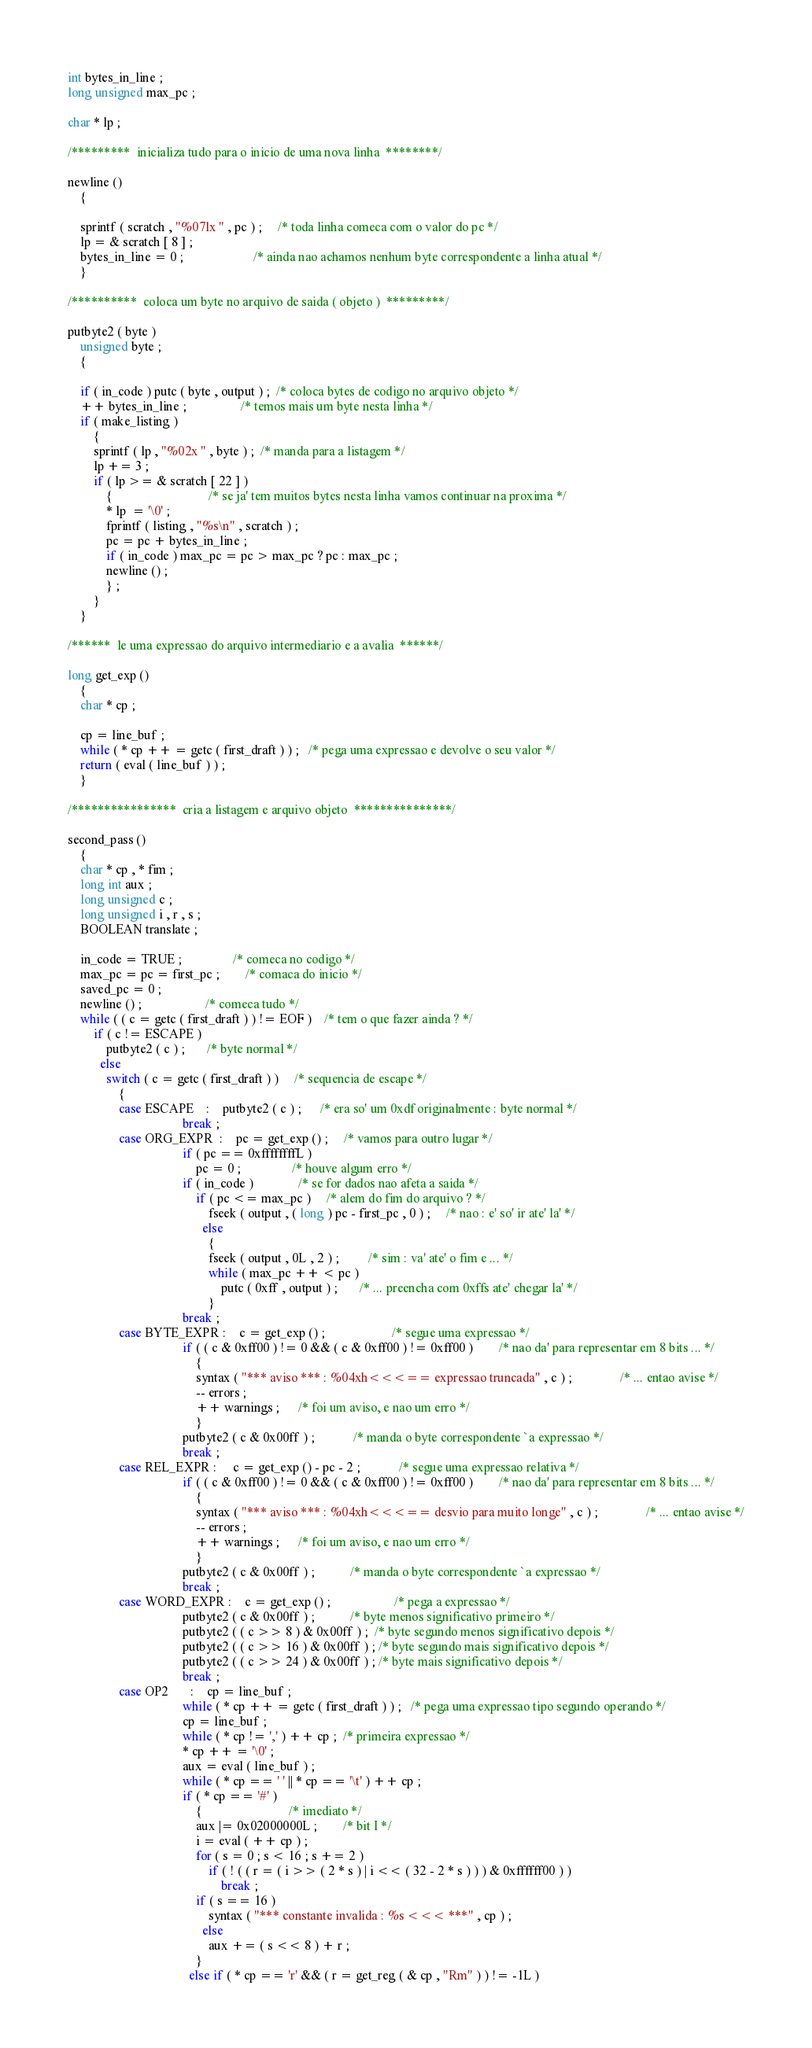Convert code to text. <code><loc_0><loc_0><loc_500><loc_500><_C_>
int bytes_in_line ;
long unsigned max_pc ;

char * lp ;

/*********  inicializa tudo para o inicio de uma nova linha  ********/

newline ()
    {

    sprintf ( scratch , "%07lx " , pc ) ;     /* toda linha comeca com o valor do pc */
    lp = & scratch [ 8 ] ;
    bytes_in_line = 0 ;                      /* ainda nao achamos nenhum byte correspondente a linha atual */
    }

/**********  coloca um byte no arquivo de saida ( objeto )  *********/

putbyte2 ( byte )
    unsigned byte ;
    {

    if ( in_code ) putc ( byte , output ) ;  /* coloca bytes de codigo no arquivo objeto */
    ++ bytes_in_line ;                 /* temos mais um byte nesta linha */
    if ( make_listing )
        {
        sprintf ( lp , "%02x " , byte ) ;  /* manda para a listagem */
        lp += 3 ;
        if ( lp >= & scratch [ 22 ] )
            {                              /* se ja' tem muitos bytes nesta linha vamos continuar na proxima */
            * lp  = '\0' ;
            fprintf ( listing , "%s\n" , scratch ) ;
            pc = pc + bytes_in_line ;
            if ( in_code ) max_pc = pc > max_pc ? pc : max_pc ;
            newline () ;
            } ;
        }
    }

/******  le uma expressao do arquivo intermediario e a avalia  ******/

long get_exp ()
    {
    char * cp ;

    cp = line_buf ;
    while ( * cp ++ = getc ( first_draft ) ) ;   /* pega uma expressao e devolve o seu valor */
    return ( eval ( line_buf ) ) ;
    }

/****************  cria a listagem e arquivo objeto  ***************/

second_pass ()
    {
    char * cp , * fim ;
    long int aux ;
    long unsigned c ;
    long unsigned i , r , s ;
    BOOLEAN translate ;

    in_code = TRUE ;                /* comeca no codigo */
    max_pc = pc = first_pc ;        /* comaca do inicio */
    saved_pc = 0 ;
    newline () ;                    /* comeca tudo */
    while ( ( c = getc ( first_draft ) ) != EOF )    /* tem o que fazer ainda ? */
        if ( c != ESCAPE )
            putbyte2 ( c ) ;       /* byte normal */
          else
            switch ( c = getc ( first_draft ) )     /* sequencia de escape */
                {
                case ESCAPE    :    putbyte2 ( c ) ;      /* era so' um 0xdf originalmente : byte normal */
                                    break ;
                case ORG_EXPR  :    pc = get_exp () ;     /* vamos para outro lugar */
                                    if ( pc == 0xffffffffL )
                                        pc = 0 ;                /* houve algum erro */
                                    if ( in_code )              /* se for dados nao afeta a saida */
                                        if ( pc <= max_pc )     /* alem do fim do arquivo ? */
                                            fseek ( output , ( long ) pc - first_pc , 0 ) ;     /* nao : e' so' ir ate' la' */
                                          else
                                            {
                                            fseek ( output , 0L , 2 ) ;         /* sim : va' ate' o fim e ... */
                                            while ( max_pc ++ < pc )
                                                putc ( 0xff , output ) ;       /* ... preencha com 0xffs ate' chegar la' */
                                            }
                                    break ;
                case BYTE_EXPR :    c = get_exp () ;                     /* segue uma expressao */
                                    if ( ( c & 0xff00 ) != 0 && ( c & 0xff00 ) != 0xff00 )        /* nao da' para representar em 8 bits ... */
                                        {
                                        syntax ( "*** aviso *** : %04xh<<<== expressao truncada" , c ) ;               /* ... entao avise */
                                        -- errors ;
                                        ++ warnings ;      /* foi um aviso, e nao um erro */
                                        }
                                    putbyte2 ( c & 0x00ff ) ;            /* manda o byte correspondente `a expressao */
                                    break ;
                case REL_EXPR :     c = get_exp () - pc - 2 ;            /* segue uma expressao relativa */
                                    if ( ( c & 0xff00 ) != 0 && ( c & 0xff00 ) != 0xff00 )        /* nao da' para representar em 8 bits ... */
                                        {
                                        syntax ( "*** aviso *** : %04xh<<<== desvio para muito longe" , c ) ;               /* ... entao avise */
                                        -- errors ;
                                        ++ warnings ;      /* foi um aviso, e nao um erro */
                                        }
                                    putbyte2 ( c & 0x00ff ) ;           /* manda o byte correspondente `a expressao */
                                    break ;
                case WORD_EXPR :    c = get_exp () ;                    /* pega a expressao */
                                    putbyte2 ( c & 0x00ff ) ;           /* byte menos significativo primeiro */
                                    putbyte2 ( ( c >> 8 ) & 0x00ff ) ;  /* byte segundo menos significativo depois */
                                    putbyte2 ( ( c >> 16 ) & 0x00ff ) ; /* byte segundo mais significativo depois */
                                    putbyte2 ( ( c >> 24 ) & 0x00ff ) ; /* byte mais significativo depois */
                                    break ;
                case OP2       :    cp = line_buf ;
                                    while ( * cp ++ = getc ( first_draft ) ) ;   /* pega uma expressao tipo segundo operando */
                                    cp = line_buf ;
                                    while ( * cp != ',' ) ++ cp ;  /* primeira expressao */
                                    * cp ++ = '\0' ;
                                    aux = eval ( line_buf ) ;
                                    while ( * cp == ' ' || * cp == '\t' ) ++ cp ;
                                    if ( * cp == '#' )
                                        {                           /* imediato */
                                        aux |= 0x02000000L ;        /* bit I */
                                        i = eval ( ++ cp ) ;
                                        for ( s = 0 ; s < 16 ; s += 2 )
                                            if ( ! ( ( r = ( i >> ( 2 * s ) | i << ( 32 - 2 * s ) ) ) & 0xffffff00 ) )
                                                break ;
                                        if ( s == 16 )
                                            syntax ( "*** constante invalida : %s <<< ***" , cp ) ;
                                          else
                                            aux += ( s << 8 ) + r ;
                                        }
                                      else if ( * cp == 'r' && ( r = get_reg ( & cp , "Rm" ) ) != -1L )</code> 